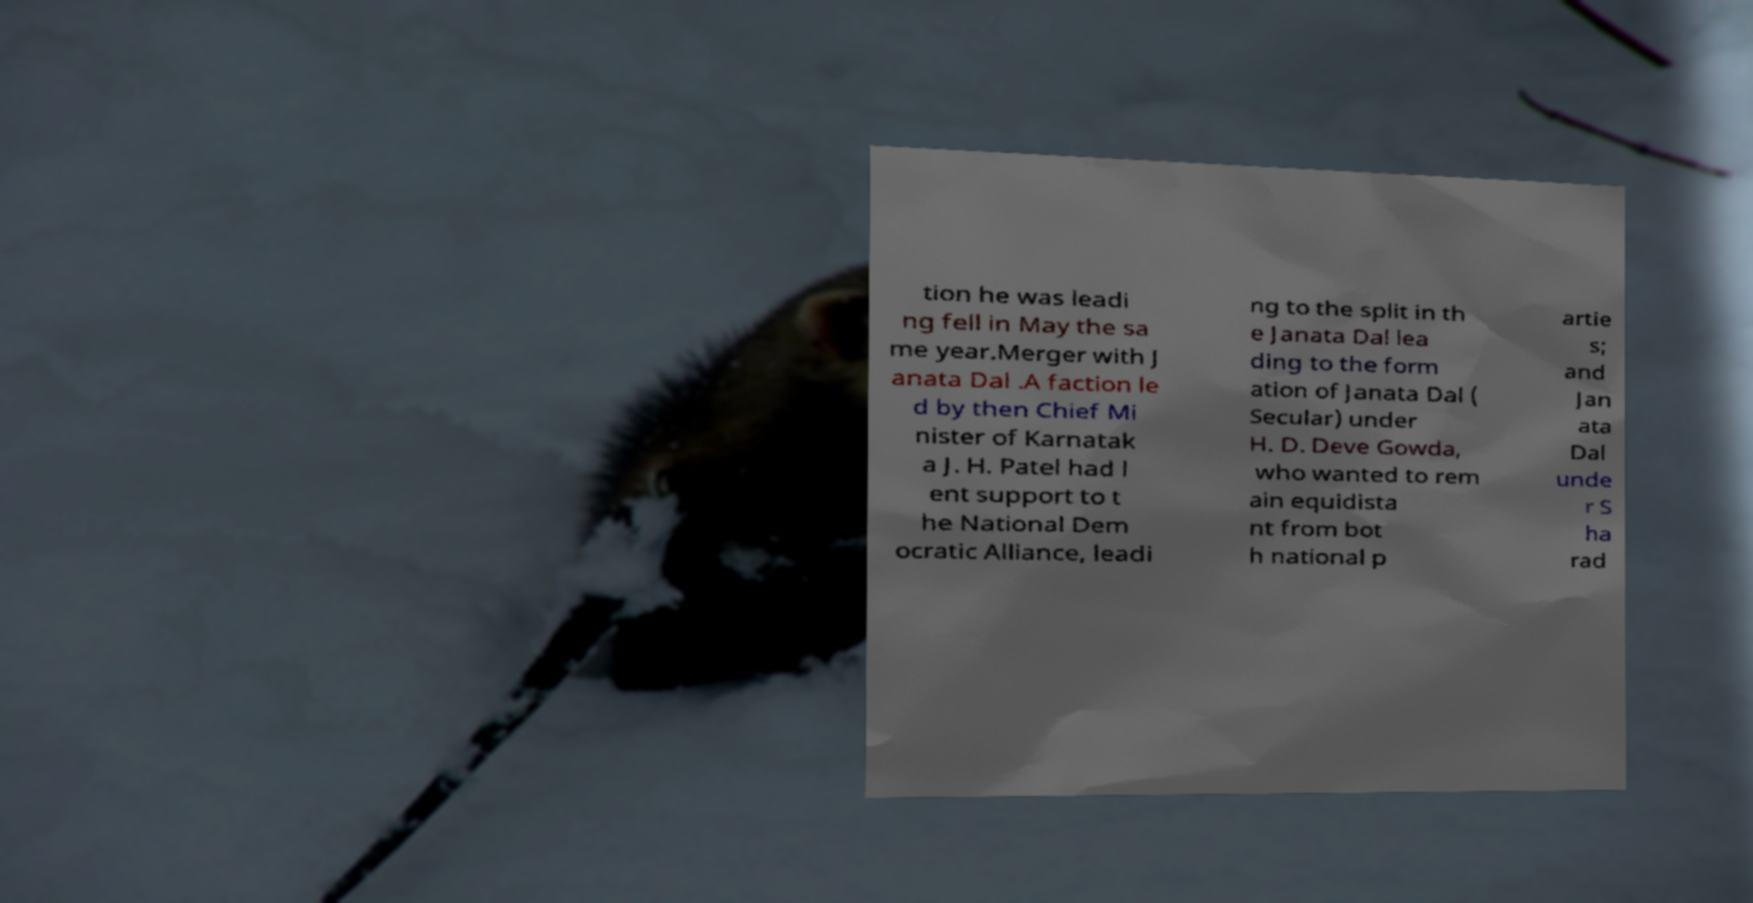Please identify and transcribe the text found in this image. tion he was leadi ng fell in May the sa me year.Merger with J anata Dal .A faction le d by then Chief Mi nister of Karnatak a J. H. Patel had l ent support to t he National Dem ocratic Alliance, leadi ng to the split in th e Janata Dal lea ding to the form ation of Janata Dal ( Secular) under H. D. Deve Gowda, who wanted to rem ain equidista nt from bot h national p artie s; and Jan ata Dal unde r S ha rad 